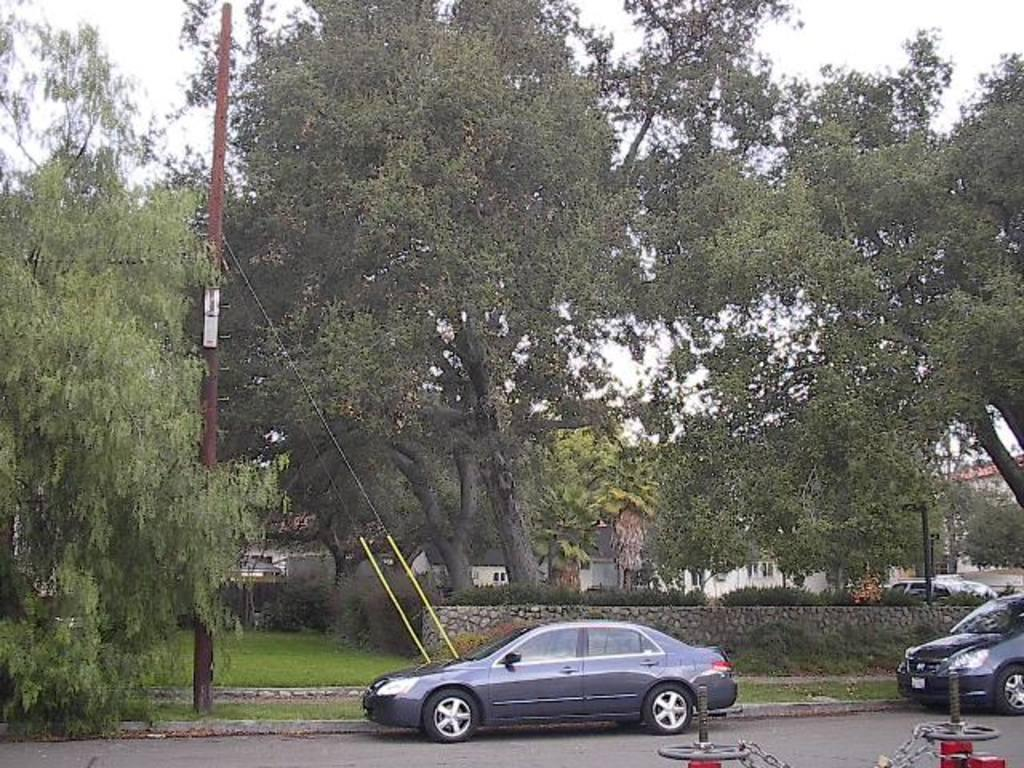What is happening on the road in the image? There are vehicles on the road in the image. Can you describe one of the vehicles? One of the vehicles is gray. What can be seen in the background of the image? There are trees and the sky visible in the background of the image. What color are the trees? The trees are green. What color is the sky in the image? The sky is white in the image. Can you tell me how many tigers are walking on the road in the image? There are no tigers present in the image; it features vehicles on the road. What type of government policy is being discussed in the image? There is no discussion of government policy in the image; it focuses on vehicles and the surrounding environment. 